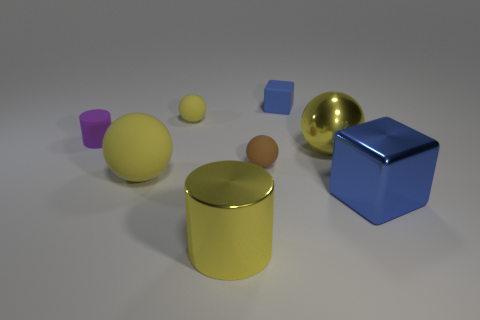Subtract all yellow spheres. How many spheres are left? 1 Add 1 tiny yellow objects. How many objects exist? 9 Subtract all brown balls. How many balls are left? 3 Subtract all cubes. How many objects are left? 6 Subtract 1 cylinders. How many cylinders are left? 1 Subtract all green spheres. How many red cylinders are left? 0 Add 6 tiny matte balls. How many tiny matte balls are left? 8 Add 6 tiny matte spheres. How many tiny matte spheres exist? 8 Subtract 0 gray cubes. How many objects are left? 8 Subtract all green cylinders. Subtract all yellow cubes. How many cylinders are left? 2 